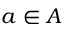<formula> <loc_0><loc_0><loc_500><loc_500>a \in A</formula> 